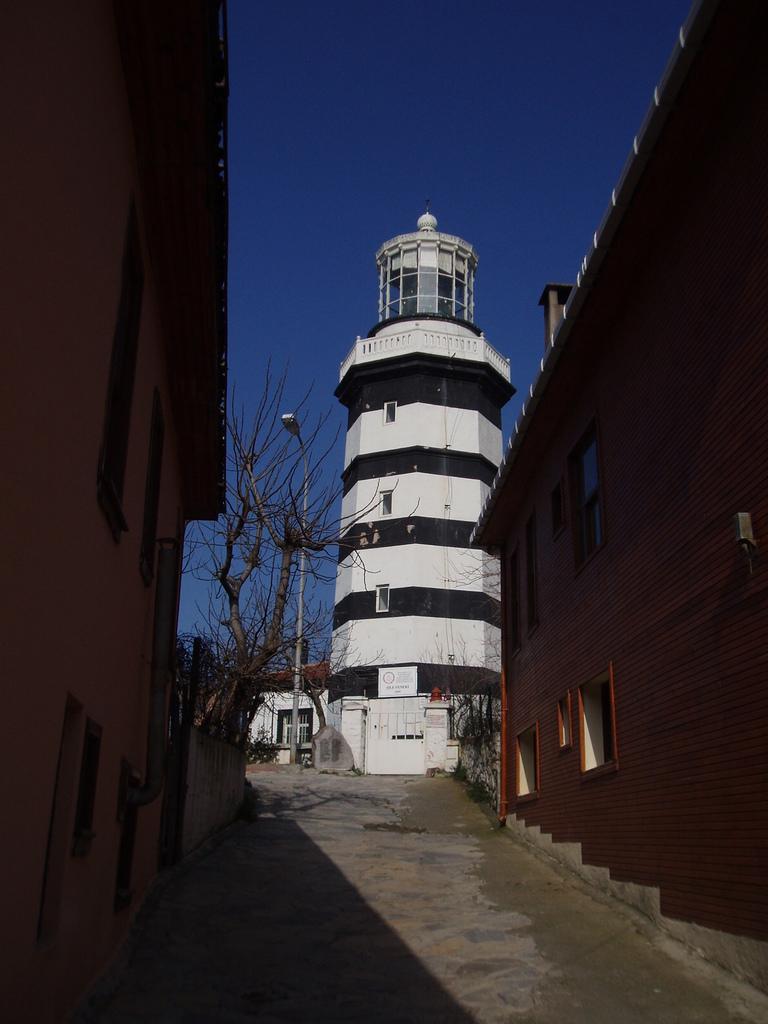How would you summarize this image in a sentence or two? In this image there are buildings. In the center there is a path. There are trees and a street light pole in the image. At the top there is the sky. 